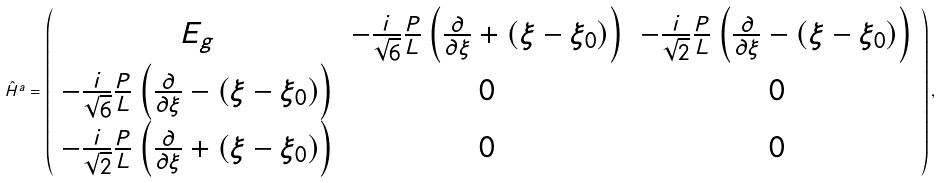<formula> <loc_0><loc_0><loc_500><loc_500>\hat { H } ^ { a } = \left ( \begin{array} { c c c } E _ { g } & - \frac { i } { \sqrt { 6 } } \frac { P } { L } \left ( \frac { \partial } { \partial \xi } + ( \xi - \xi _ { 0 } ) \right ) & - \frac { i } { \sqrt { 2 } } \frac { P } { L } \left ( \frac { \partial } { \partial \xi } - ( \xi - \xi _ { 0 } ) \right ) \\ - \frac { i } { \sqrt { 6 } } \frac { P } { L } \left ( \frac { \partial } { \partial \xi } - ( \xi - \xi _ { 0 } ) \right ) & 0 & 0 \\ - \frac { i } { \sqrt { 2 } } \frac { P } { L } \left ( \frac { \partial } { \partial \xi } + ( \xi - \xi _ { 0 } ) \right ) & 0 & 0 \end{array} \right ) ,</formula> 